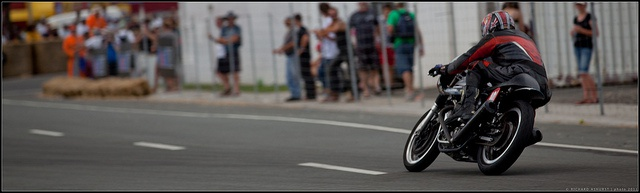Describe the objects in this image and their specific colors. I can see motorcycle in black, gray, darkgray, and lightgray tones, people in black, gray, maroon, and brown tones, people in black, gray, navy, and teal tones, people in black, gray, and maroon tones, and people in black, gray, maroon, and navy tones in this image. 